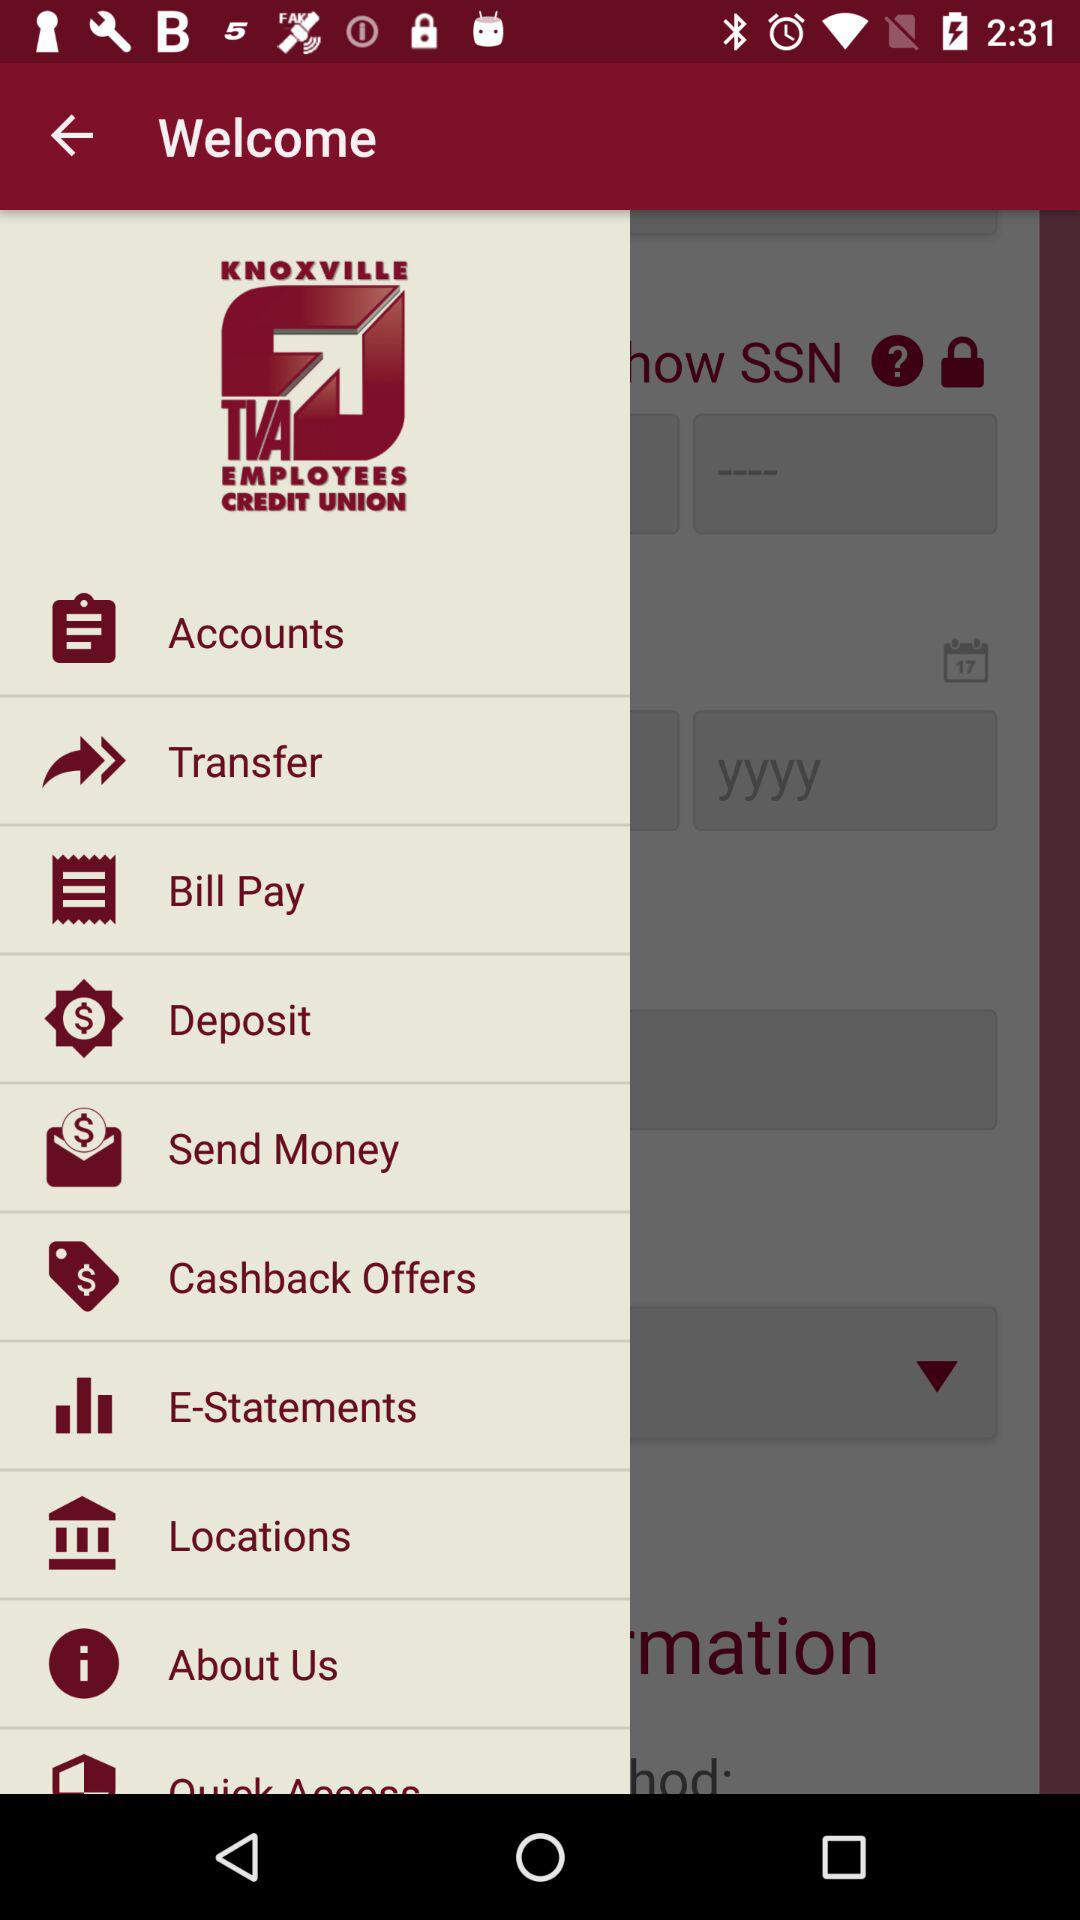What is the app name? The app name is "KNOXVILLE TVA EMPLOYEES CREDIT UNION". 